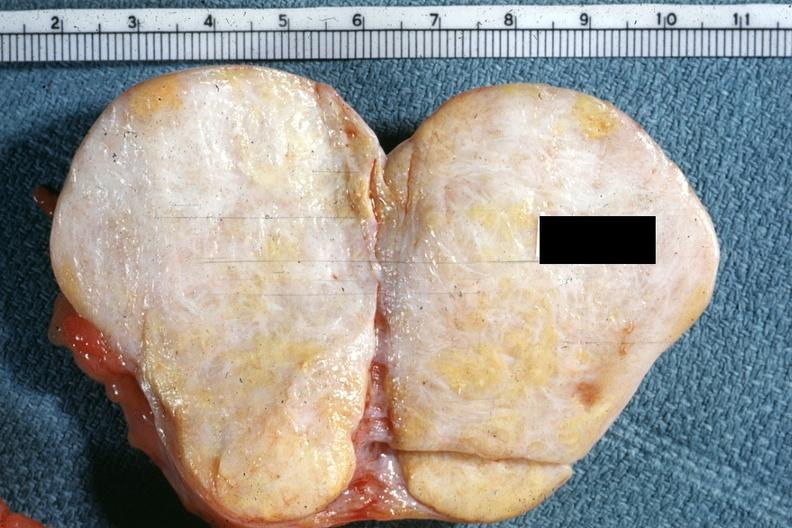what is quite obvious?
Answer the question using a single word or phrase. This typical thecoma with yellow foci 